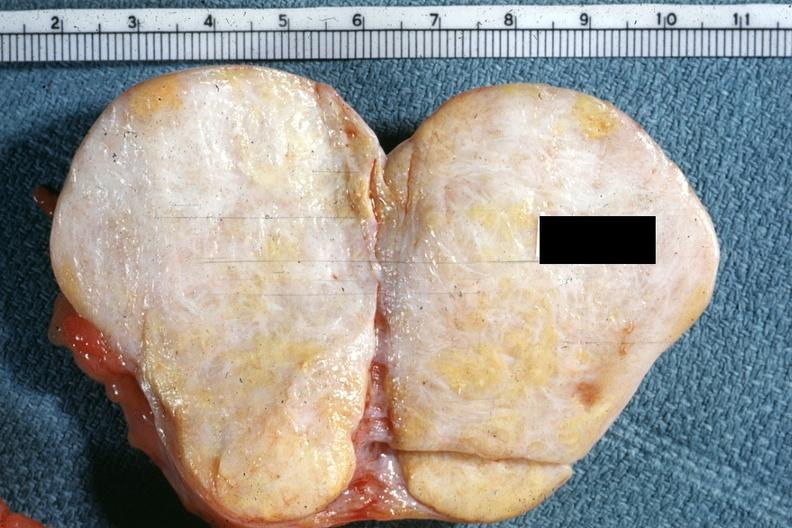what is quite obvious?
Answer the question using a single word or phrase. This typical thecoma with yellow foci 